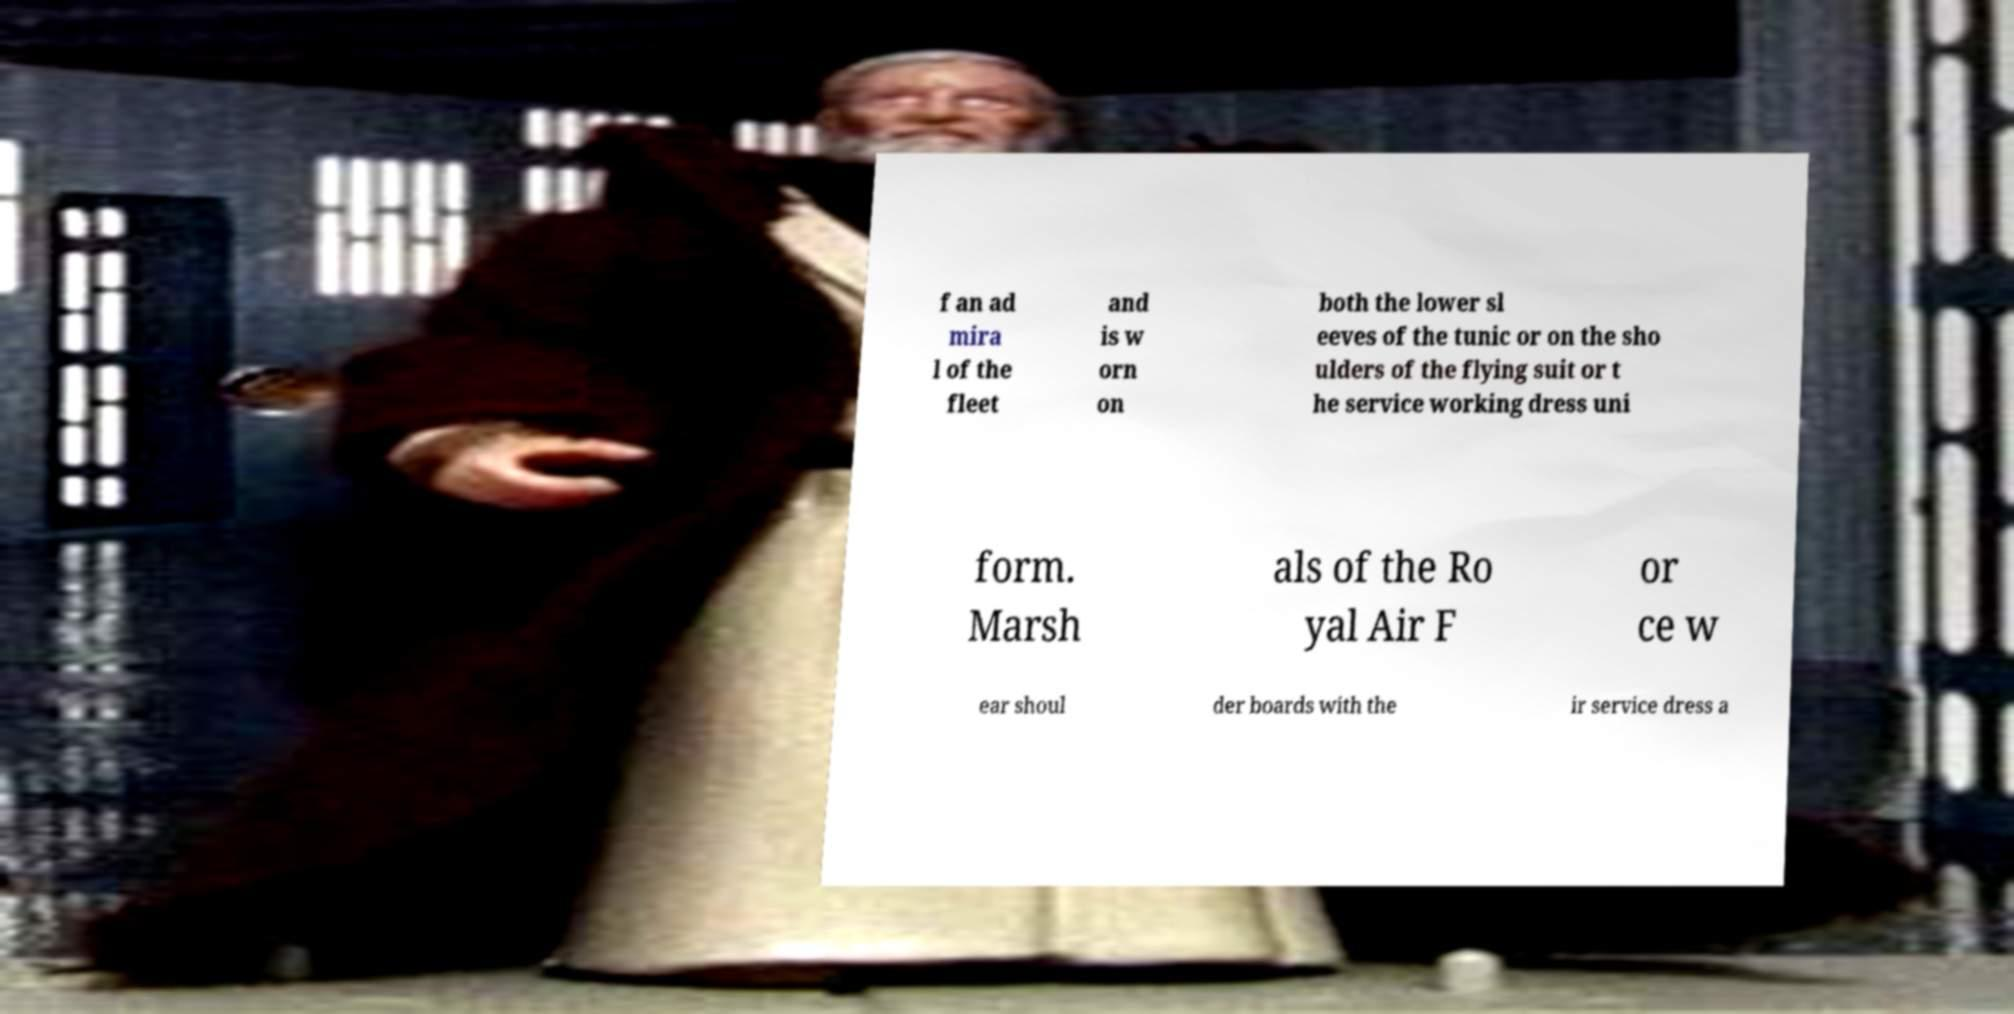Can you accurately transcribe the text from the provided image for me? f an ad mira l of the fleet and is w orn on both the lower sl eeves of the tunic or on the sho ulders of the flying suit or t he service working dress uni form. Marsh als of the Ro yal Air F or ce w ear shoul der boards with the ir service dress a 